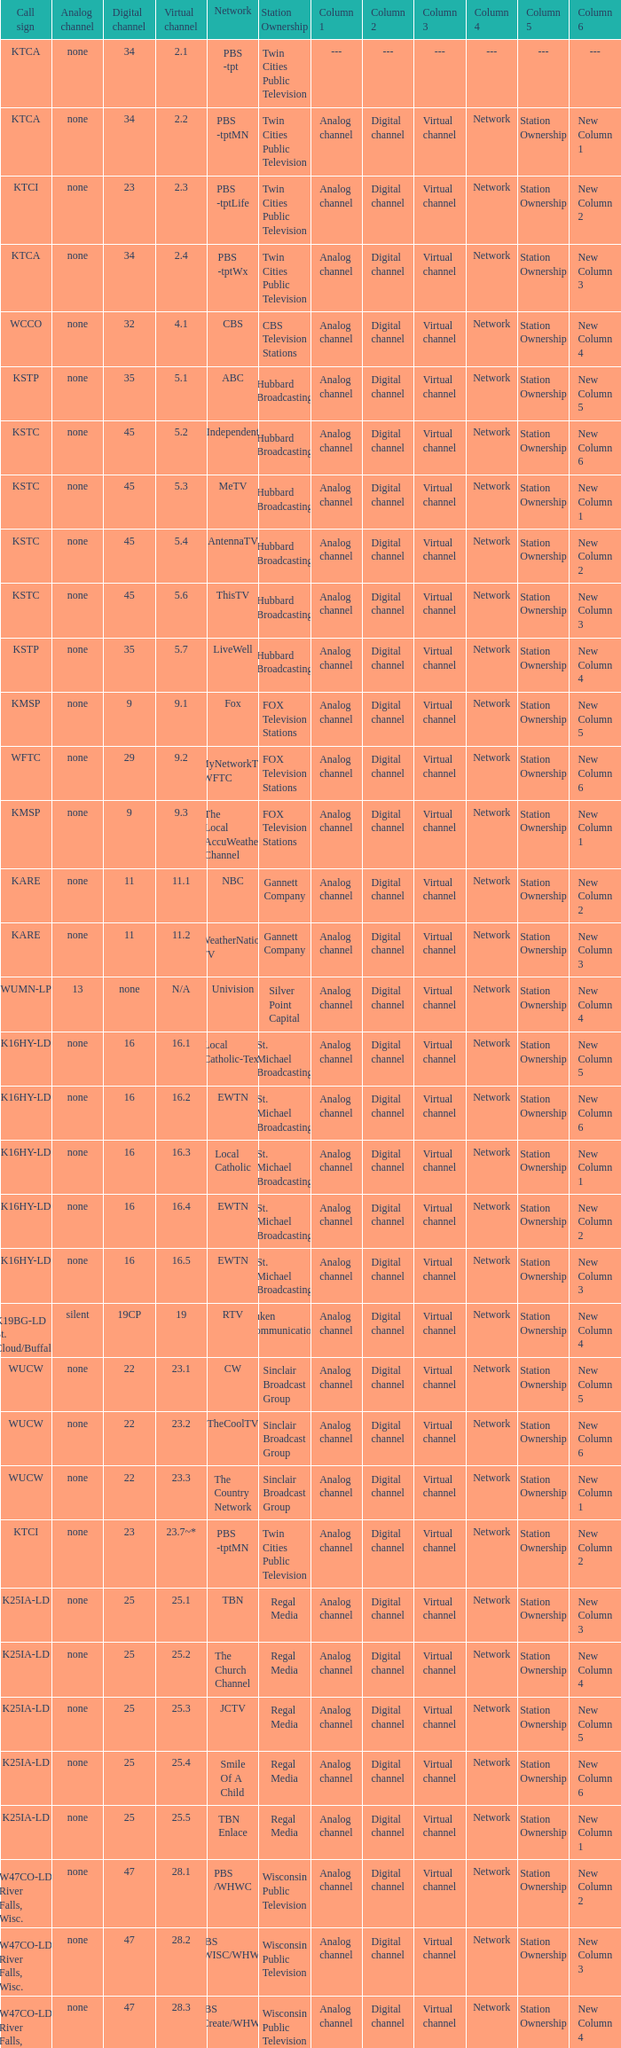Digital channel of 32 belongs to what analog channel? None. 